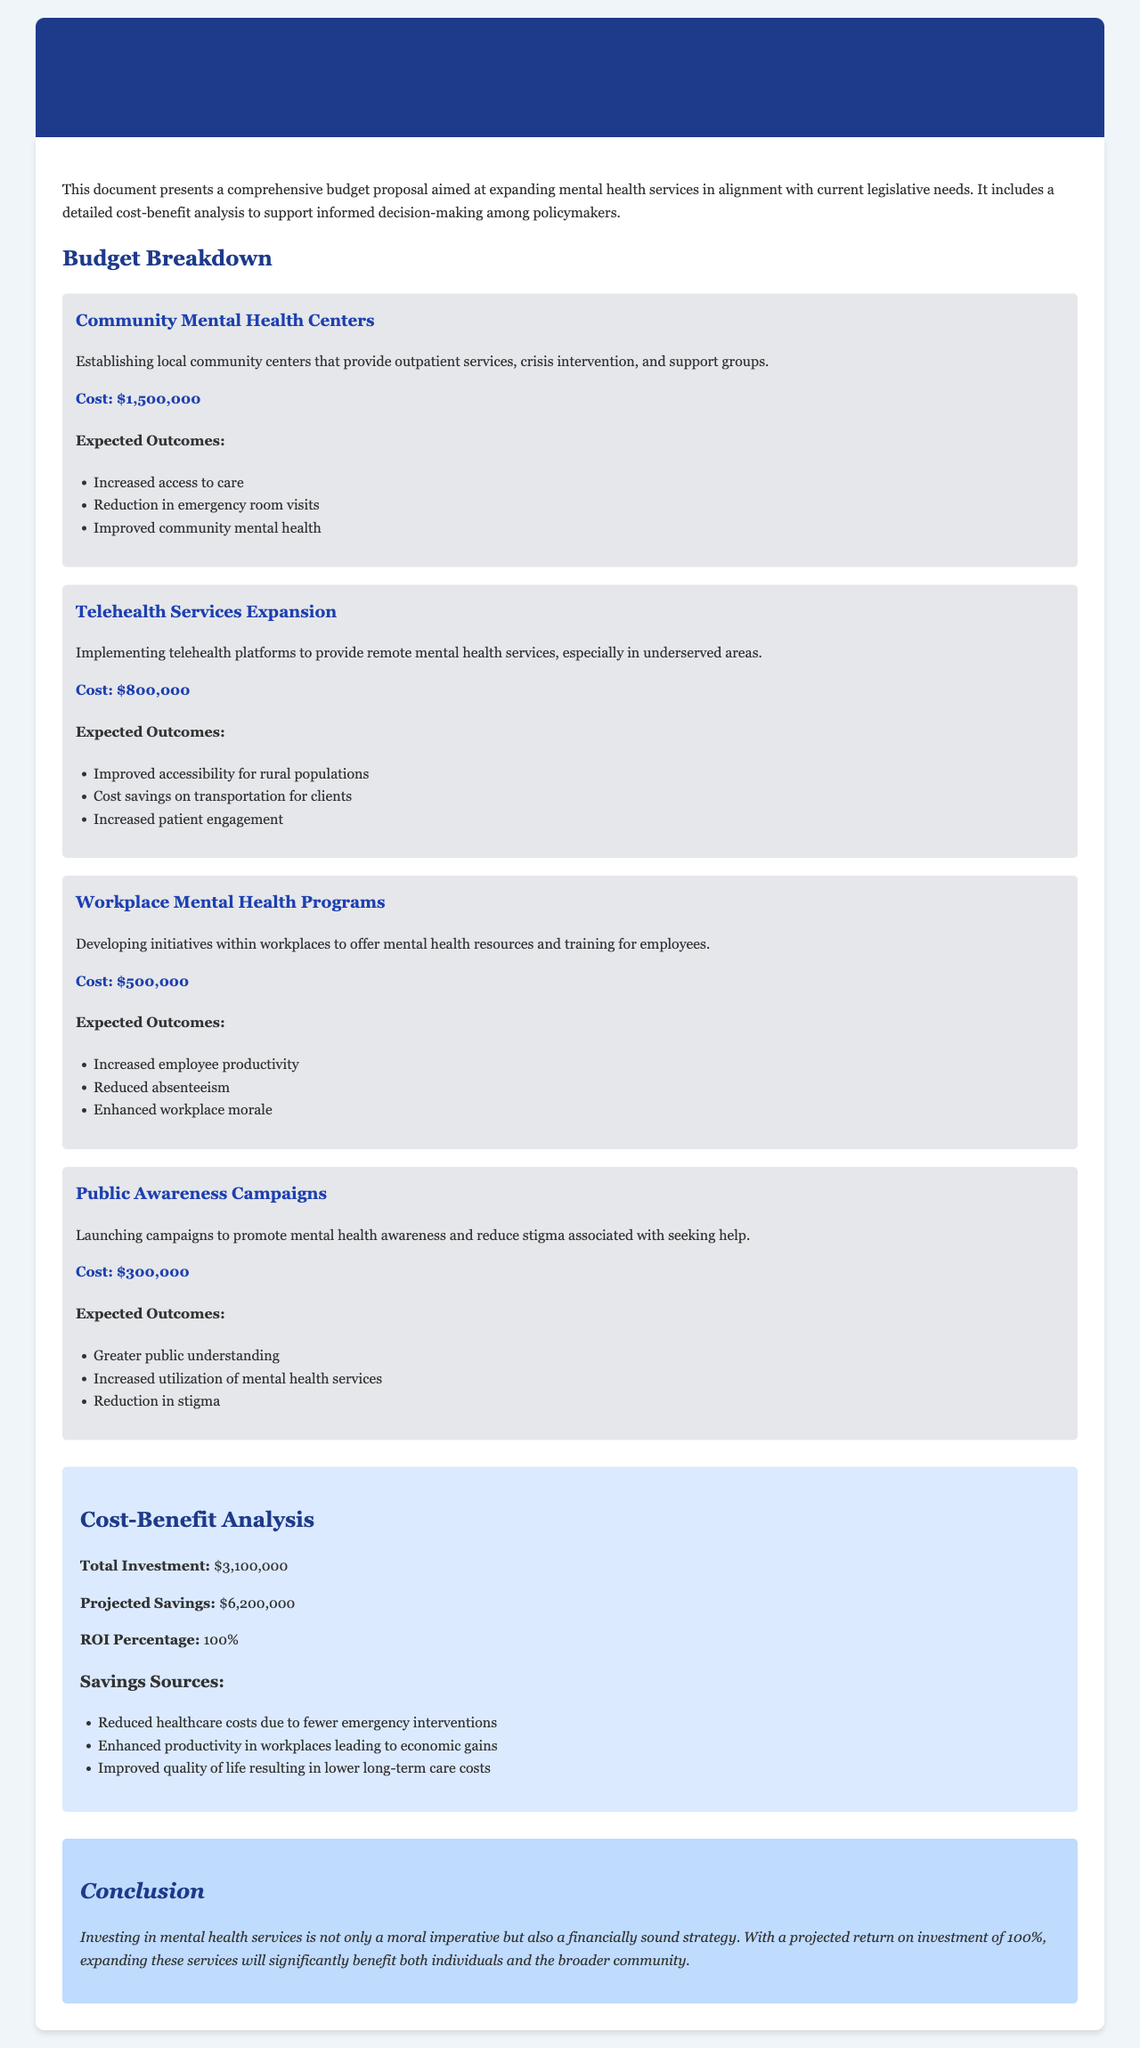What is the total investment in mental health services? The total investment is stated in the cost-benefit analysis section of the document.
Answer: $3,100,000 What is the cost of establishing Community Mental Health Centers? The cost is provided in the budget breakdown for each program.
Answer: $1,500,000 What is the expected outcome of the Public Awareness Campaigns? The outcomes are listed under each program's description in the document.
Answer: Greater public understanding How much is projected to be saved through this investment? The projected savings can be found in the cost-benefit analysis section.
Answer: $6,200,000 What percentage is the projected return on investment (ROI)? The ROI percentage is explicitly mentioned in the cost-benefit analysis part of the document.
Answer: 100% What initiative focuses on providing remote mental health services? The initiative name is listed in the programs section where various mental health services are outlined.
Answer: Telehealth Services Expansion What is one of the expected outcomes of the Workplace Mental Health Programs? The expected outcomes are detailed under the program description.
Answer: Increased employee productivity What is the cost of Public Awareness Campaigns? The cost is detailed in the budget breakdown for that specific program.
Answer: $300,000 What funding amount is allocated for Telehealth Services Expansion? This funding amount is provided in the budget breakdown section of the document.
Answer: $800,000 